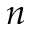Convert formula to latex. <formula><loc_0><loc_0><loc_500><loc_500>n</formula> 